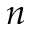Convert formula to latex. <formula><loc_0><loc_0><loc_500><loc_500>n</formula> 